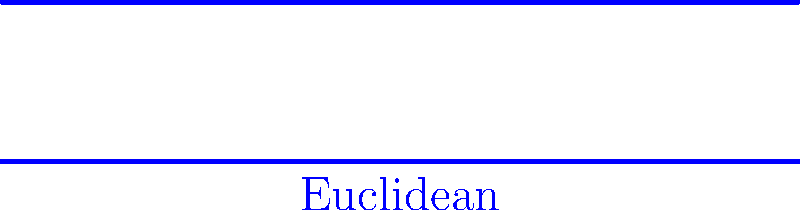In the context of Non-Euclidean Geometry, which statement best describes the behavior of parallel lines in hyperbolic geometry compared to Euclidean geometry, as illustrated in the diagram? To answer this question, let's analyze the diagram step-by-step:

1. Euclidean Geometry:
   - The blue lines represent parallel lines in Euclidean geometry.
   - These lines maintain a constant distance from each other and never intersect.
   - This aligns with Euclid's fifth postulate, which states that parallel lines remain equidistant.

2. Hyperbolic Geometry:
   - The red curves represent parallel lines in hyperbolic geometry, shown in the Poincaré disk model.
   - These curves appear to diverge from each other as they approach the boundary of the disk.
   - In hyperbolic geometry, Euclid's fifth postulate does not hold.

3. Key Differences:
   - In Euclidean geometry, parallel lines maintain a constant distance.
   - In hyperbolic geometry, parallel lines appear to diverge.
   - The divergence in hyperbolic geometry occurs without the lines actually intersecting within the hyperbolic plane.

4. Historical Context:
   - The discovery of hyperbolic geometry in the 19th century challenged the 2000-year-old assumption that Euclidean geometry was the only possible geometric system.
   - This development had profound implications for mathematics, physics, and philosophy, much like how the Copernican revolution challenged long-held beliefs in astronomy.

5. Theological Perspective:
   - The existence of consistent non-Euclidean geometries can be seen as a reflection of God's infinite creativity in the mathematical structures of the universe.
   - Just as the Catholic Church eventually embraced heliocentrism, it has come to appreciate the beauty and significance of non-Euclidean geometries in understanding God's creation.

Therefore, the key difference is that parallel lines in hyperbolic geometry diverge, while in Euclidean geometry they remain equidistant.
Answer: Parallel lines diverge in hyperbolic geometry, remain equidistant in Euclidean geometry. 